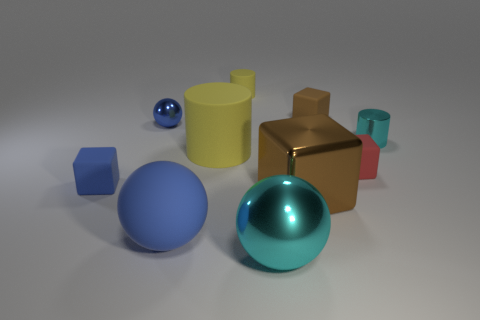Subtract 1 blocks. How many blocks are left? 3 Subtract all gray cylinders. Subtract all brown cubes. How many cylinders are left? 3 Subtract all blocks. How many objects are left? 6 Add 1 metallic things. How many metallic things are left? 5 Add 4 red matte cubes. How many red matte cubes exist? 5 Subtract 0 purple cubes. How many objects are left? 10 Subtract all big gray metal cubes. Subtract all blue rubber balls. How many objects are left? 9 